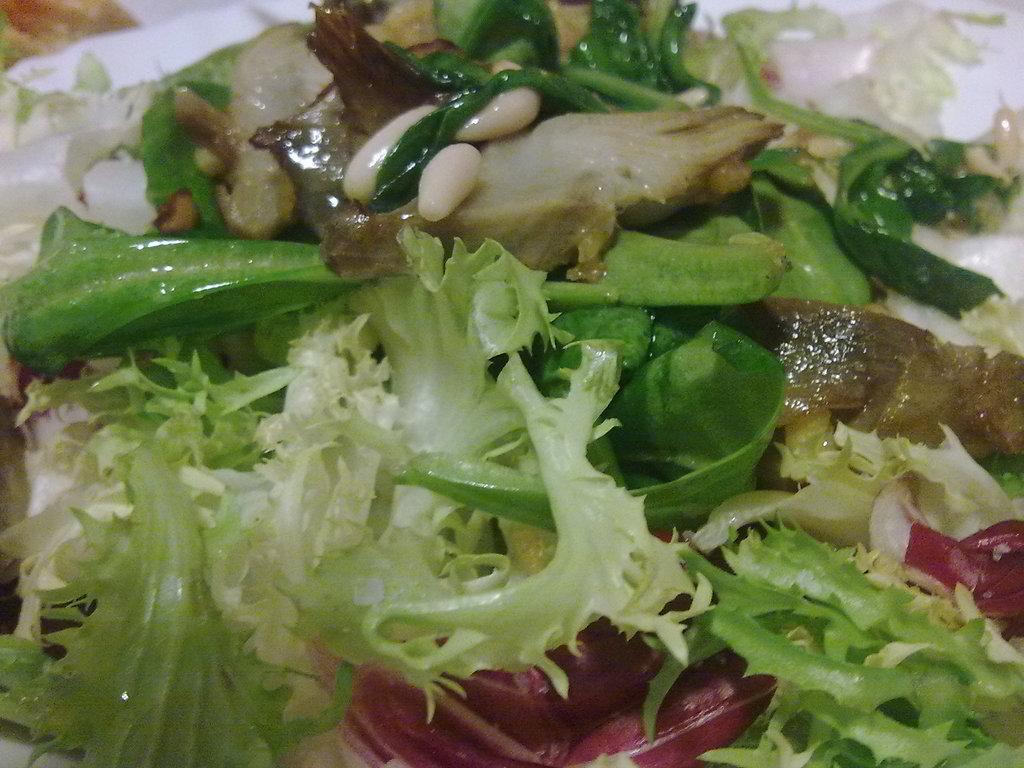Describe this image in one or two sentences. In the image we can see some food. 